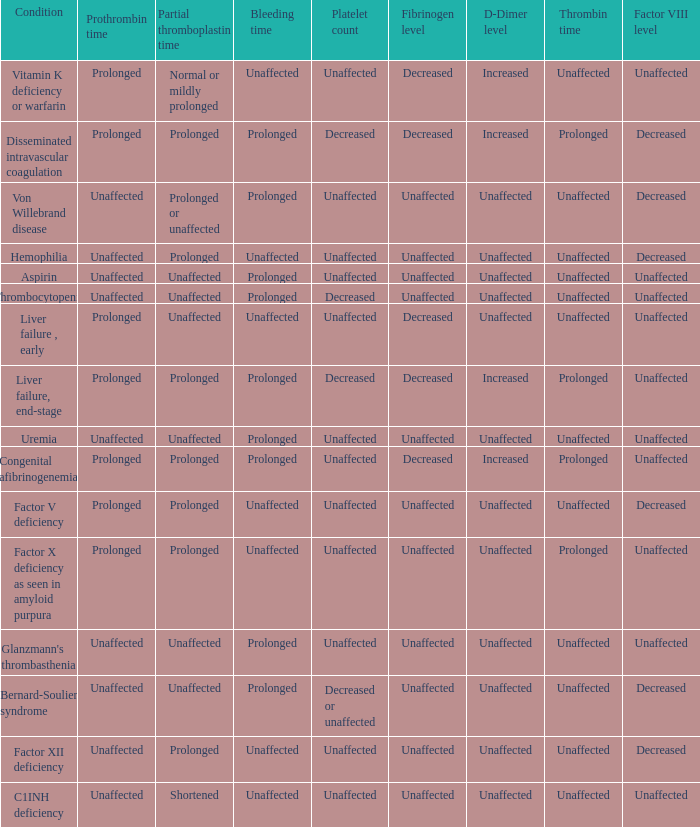Which Platelet count has a Condition of factor v deficiency? Unaffected. 